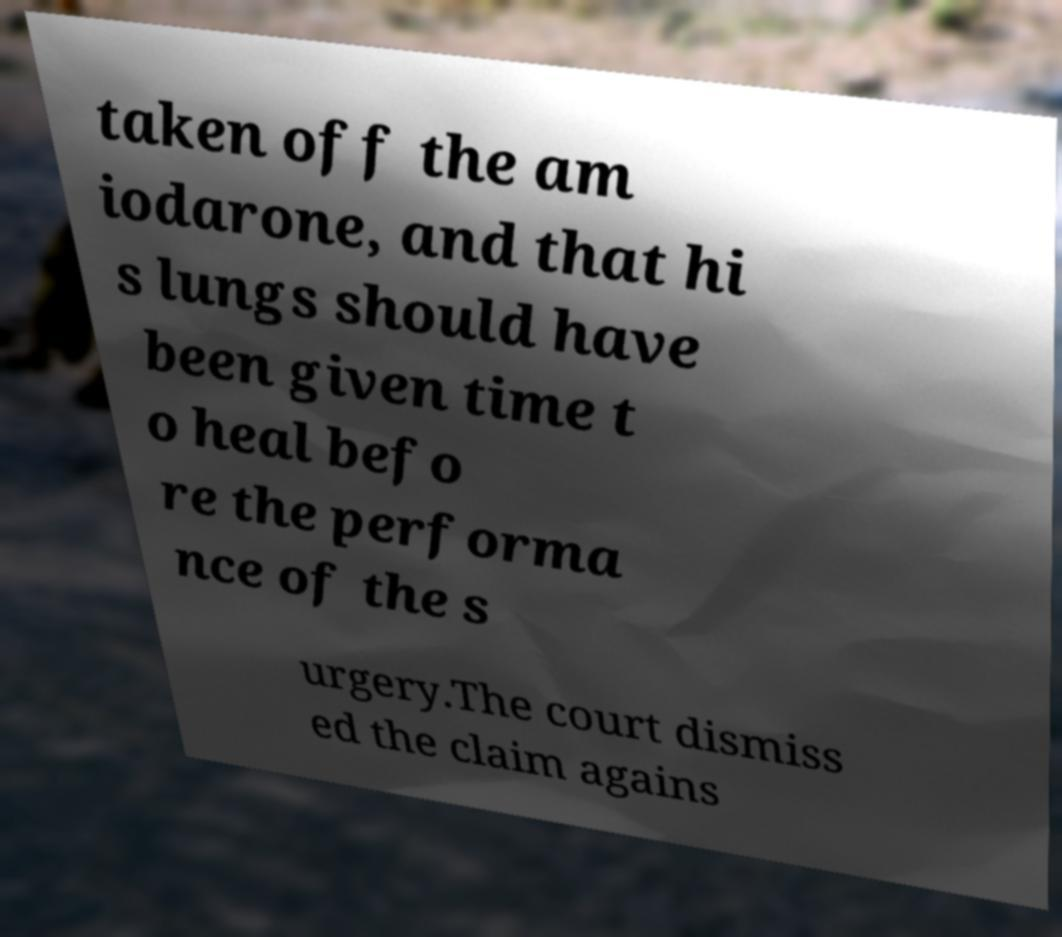Could you assist in decoding the text presented in this image and type it out clearly? taken off the am iodarone, and that hi s lungs should have been given time t o heal befo re the performa nce of the s urgery.The court dismiss ed the claim agains 